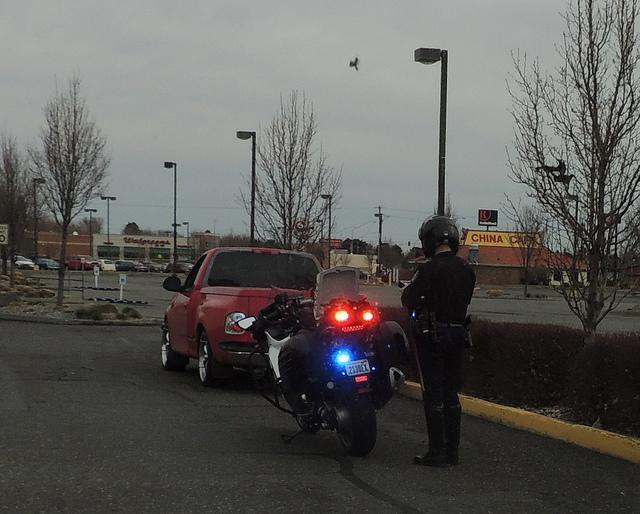How many frisbees are in the air?
Give a very brief answer. 0. 